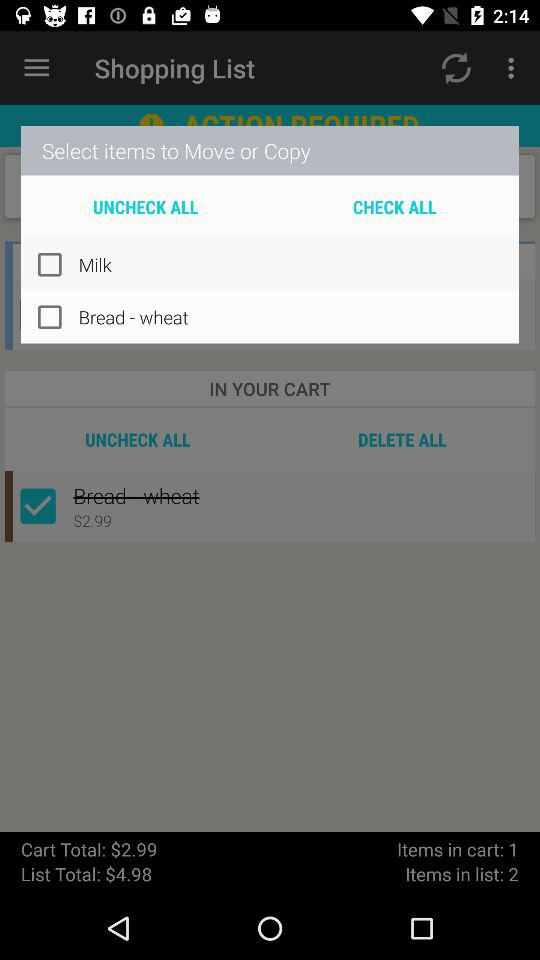What is the total cart amount? The total cart amount is $2.99. 